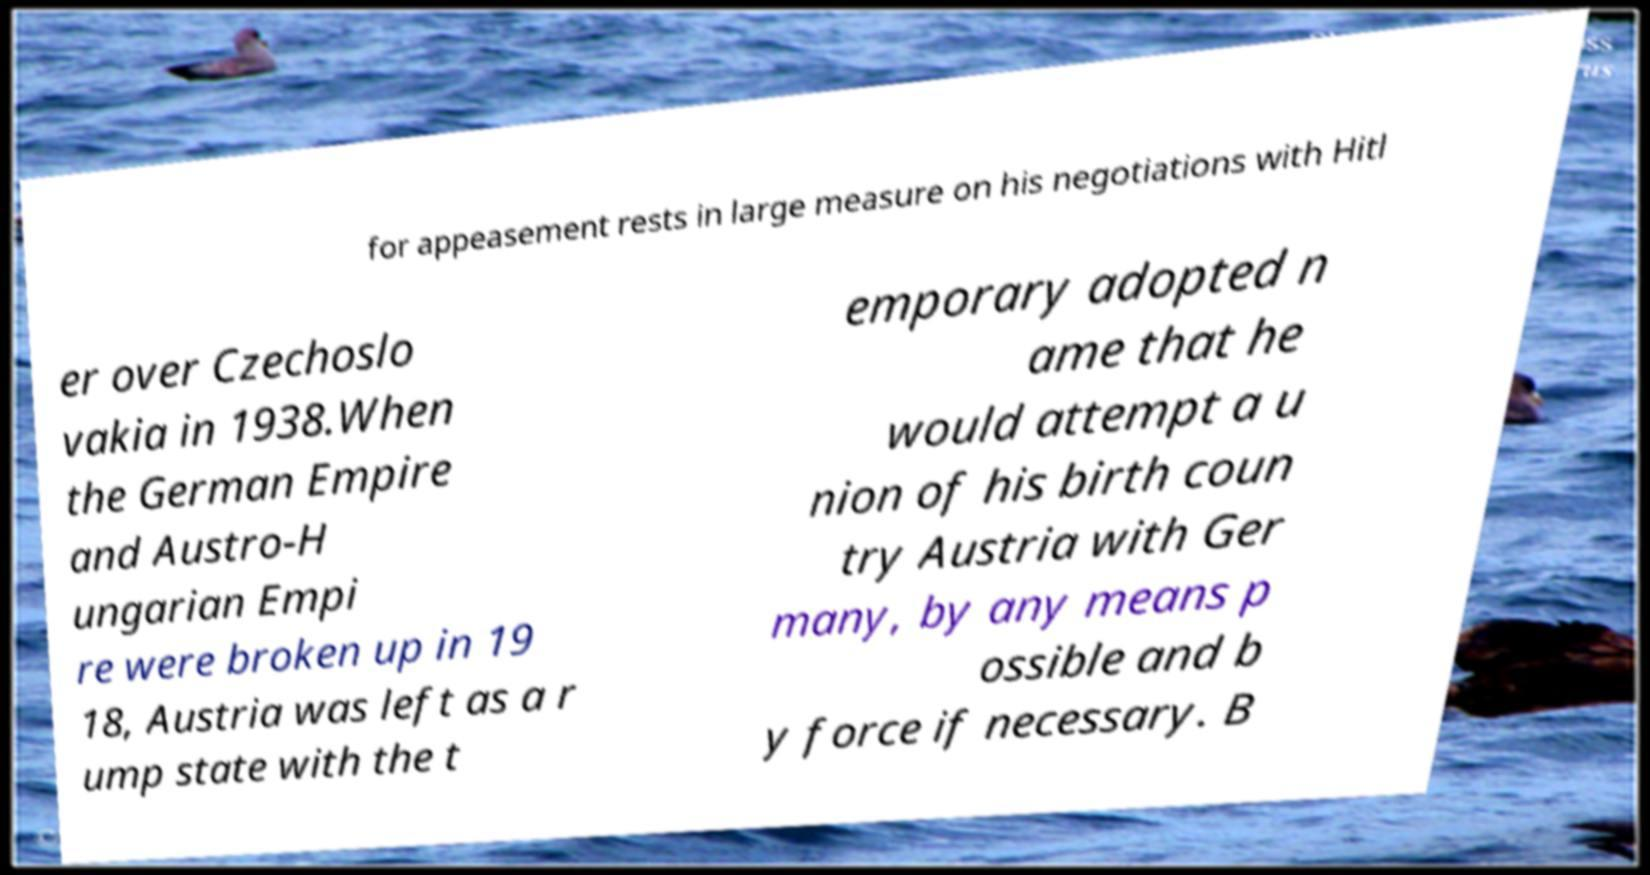For documentation purposes, I need the text within this image transcribed. Could you provide that? for appeasement rests in large measure on his negotiations with Hitl er over Czechoslo vakia in 1938.When the German Empire and Austro-H ungarian Empi re were broken up in 19 18, Austria was left as a r ump state with the t emporary adopted n ame that he would attempt a u nion of his birth coun try Austria with Ger many, by any means p ossible and b y force if necessary. B 